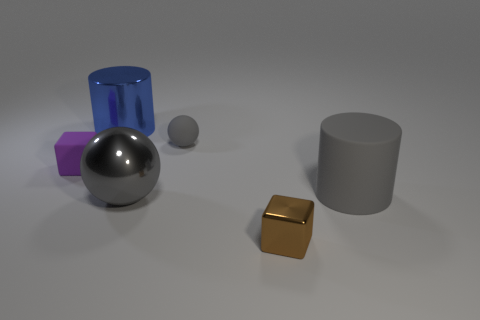There is a big blue object; what shape is it?
Provide a succinct answer. Cylinder. What number of other objects are the same material as the purple cube?
Offer a very short reply. 2. What size is the gray rubber object that is the same shape as the big blue shiny object?
Your response must be concise. Large. The gray sphere that is behind the cylinder in front of the shiny cylinder that is to the right of the small purple cube is made of what material?
Offer a terse response. Rubber. Are there any big red shiny objects?
Offer a terse response. No. There is a big sphere; does it have the same color as the object that is behind the small gray object?
Your response must be concise. No. What color is the large sphere?
Give a very brief answer. Gray. Are there any other things that have the same shape as the tiny metal object?
Offer a very short reply. Yes. What color is the metal object that is the same shape as the tiny gray matte thing?
Offer a terse response. Gray. Is the tiny brown object the same shape as the blue object?
Provide a short and direct response. No. 